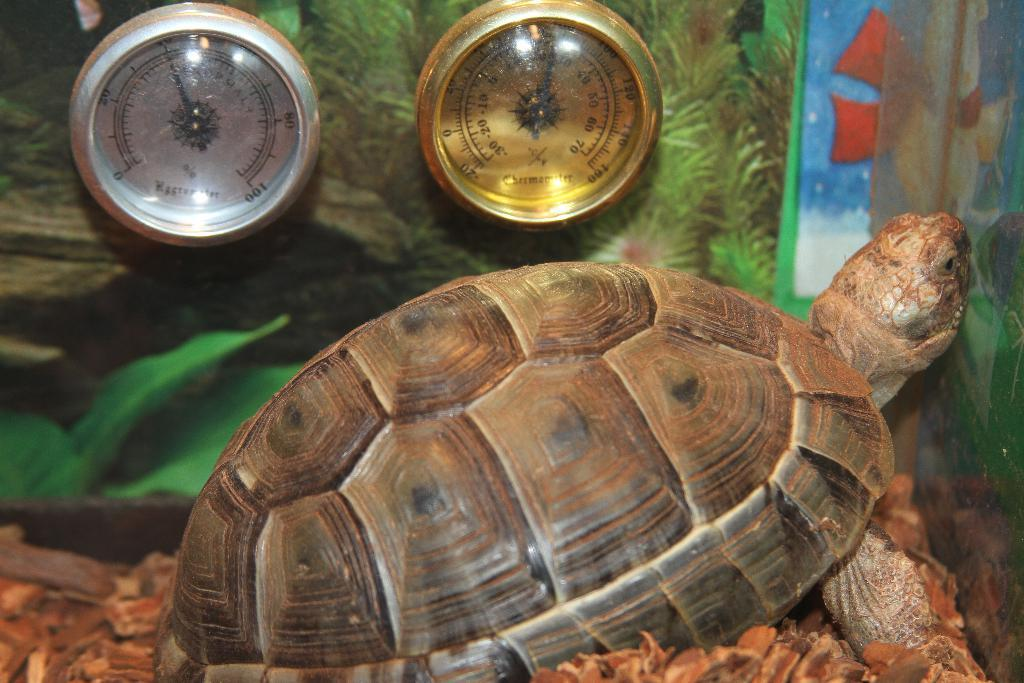What animal is the main subject of the picture? There is a tortoise in the picture. What can be seen beside the tortoise? There are two objects beside the tortoise. What other objects are present in the image? There are some other objects below the tortoise. What type of structure can be seen in the background of the image? There is no structure visible in the image; it only features a tortoise and surrounding objects. What emotion does the tortoise appear to be experiencing in the image? The tortoise's emotions cannot be determined from the image, as animals do not express emotions in the same way as humans. 